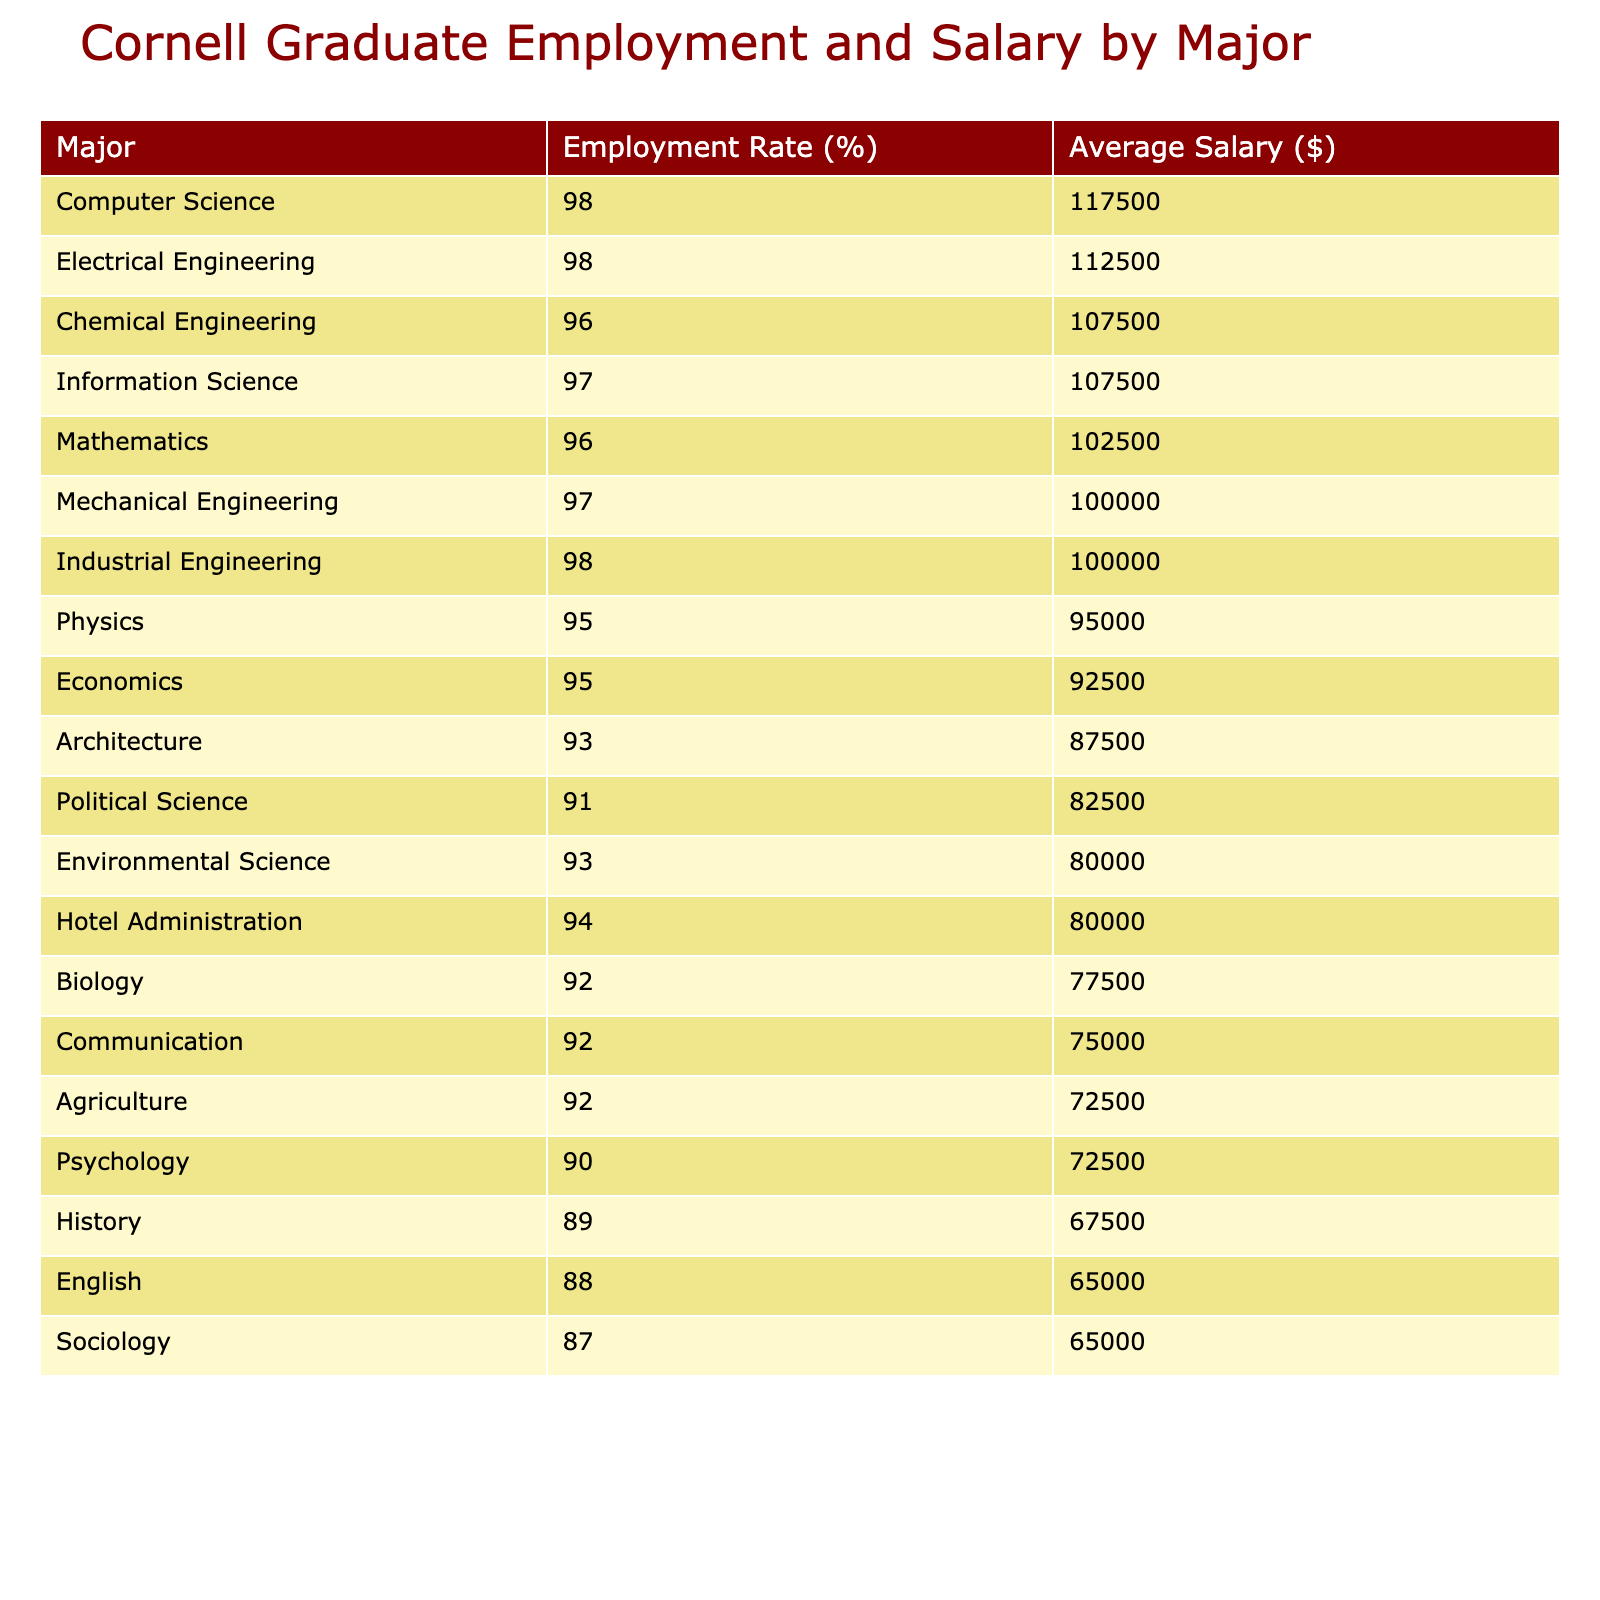What is the employment rate for Computer Science graduates? According to the table, the employment rate for Computer Science graduates is listed as 98%.
Answer: 98% Which major has the lowest average salary? To find the lowest average salary, we look at the Salary Avg column. The major Sociology has the lowest average salary of $48,000.
Answer: $48,000 Is the employment rate for Mechanical Engineering above 95%? The employment rate for Mechanical Engineering is 97%, which is indeed above 95%.
Answer: Yes What is the average salary for graduates of Economics? From the table, the Salary Avg for Economics graduates is calculated by taking the range 65,000 to 120,000, giving an average of $92,500.
Answer: $92,500 Which industry pays the highest average salary? The majors in the Technology industry, specifically Computer Science and Information Science, have average salaries of $115,000 and $105,000 respectively. Therefore, Technology has the highest average salary.
Answer: Technology How much higher is the average salary for Electrical Engineering compared to English? The average salary for Electrical Engineering graduates is $107,500, while for English graduates it is $62,000. The difference is $107,500 - $62,000 = $45,500.
Answer: $45,500 Which majors have an employment rate lower than 90%? Looking at the Employment Rate column, both English (88%) and Sociology (87%) have employment rates lower than 90%.
Answer: English, Sociology What is the average employment rate among all majors listed? By summing the employment rates (98 + 95 + 97 + 92 + 88 + 96 + 90 + 98 + 91 + 93 + 96 + 94 + 95 + 92 + 87) and dividing by the number of majors (15), we find the average is 93.3%.
Answer: 93.3% Are graduates from the Hospitality industry more likely to earn above $60,000? The average salary for Hotel Administration graduates is $77,500, which is above $60,000, indicating that graduates from the Hospitality industry are indeed likely to earn more than this threshold.
Answer: Yes 